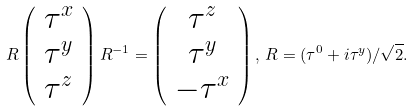Convert formula to latex. <formula><loc_0><loc_0><loc_500><loc_500>R \left ( \begin{array} { c } \tau ^ { x } \\ \tau ^ { y } \\ \tau ^ { z } \\ \end{array} \right ) R ^ { - 1 } = \left ( \begin{array} { c } \tau ^ { z } \\ \tau ^ { y } \\ - \tau ^ { x } \\ \end{array} \right ) , \, R = ( \tau ^ { 0 } + { i } \tau ^ { y } ) / \sqrt { 2 } .</formula> 